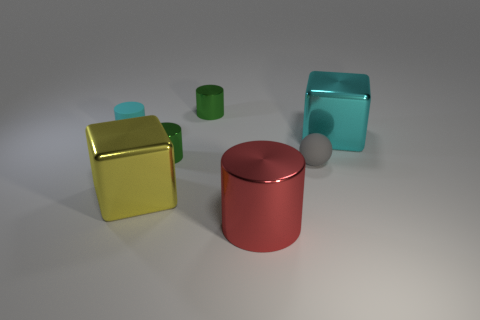Subtract 1 cylinders. How many cylinders are left? 3 Subtract all gray cylinders. Subtract all gray spheres. How many cylinders are left? 4 Add 1 gray objects. How many objects exist? 8 Subtract all cubes. How many objects are left? 5 Add 3 gray matte things. How many gray matte things are left? 4 Add 7 tiny gray spheres. How many tiny gray spheres exist? 8 Subtract 0 green balls. How many objects are left? 7 Subtract all cubes. Subtract all small red matte objects. How many objects are left? 5 